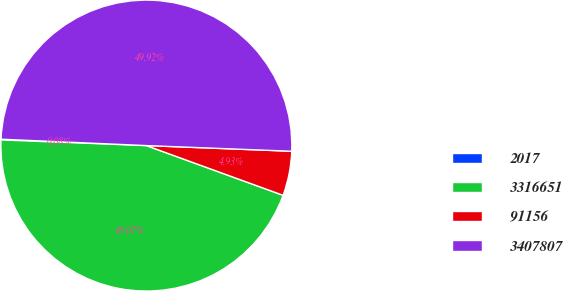<chart> <loc_0><loc_0><loc_500><loc_500><pie_chart><fcel>2017<fcel>3316651<fcel>91156<fcel>3407807<nl><fcel>0.08%<fcel>45.07%<fcel>4.93%<fcel>49.92%<nl></chart> 